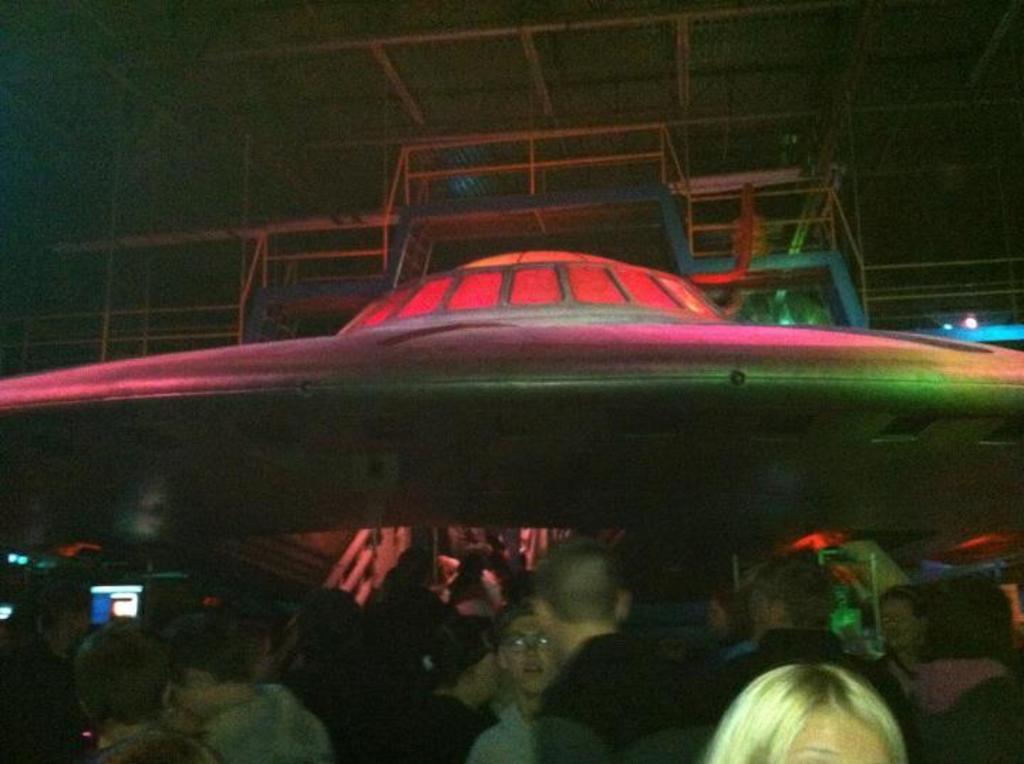Please provide a concise description of this image. In this image I can see number of people are standing over here. I can also see lights in the background and here I can see a depiction of UFO. 